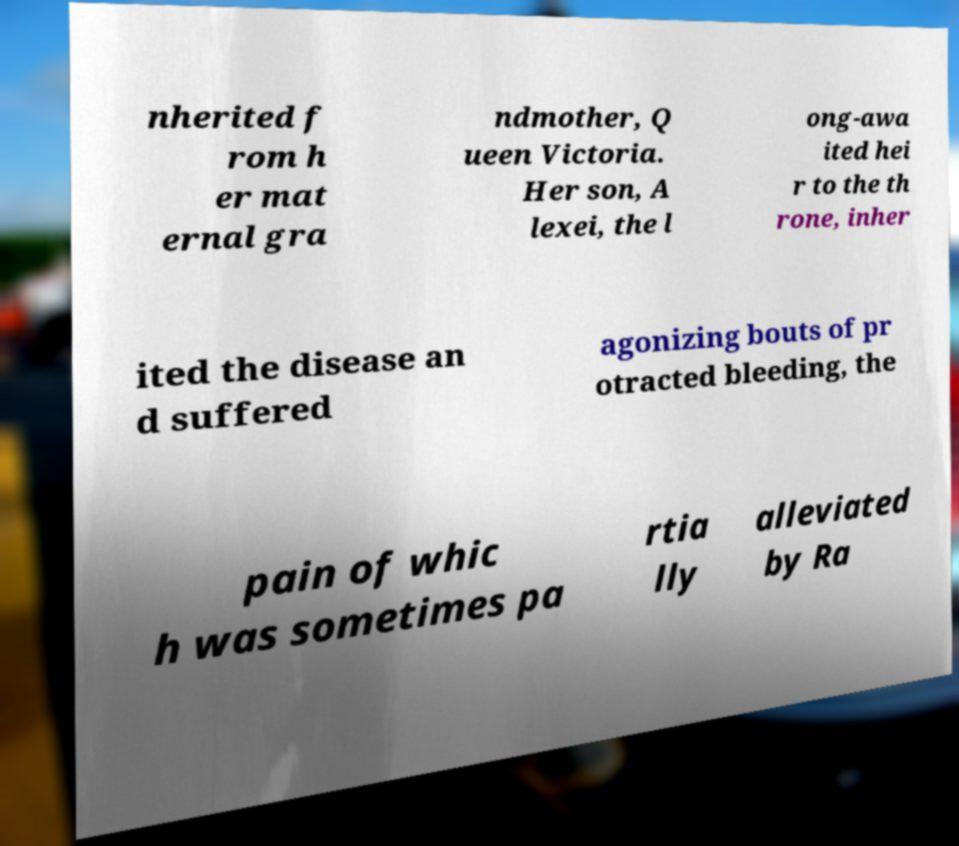Could you assist in decoding the text presented in this image and type it out clearly? nherited f rom h er mat ernal gra ndmother, Q ueen Victoria. Her son, A lexei, the l ong-awa ited hei r to the th rone, inher ited the disease an d suffered agonizing bouts of pr otracted bleeding, the pain of whic h was sometimes pa rtia lly alleviated by Ra 